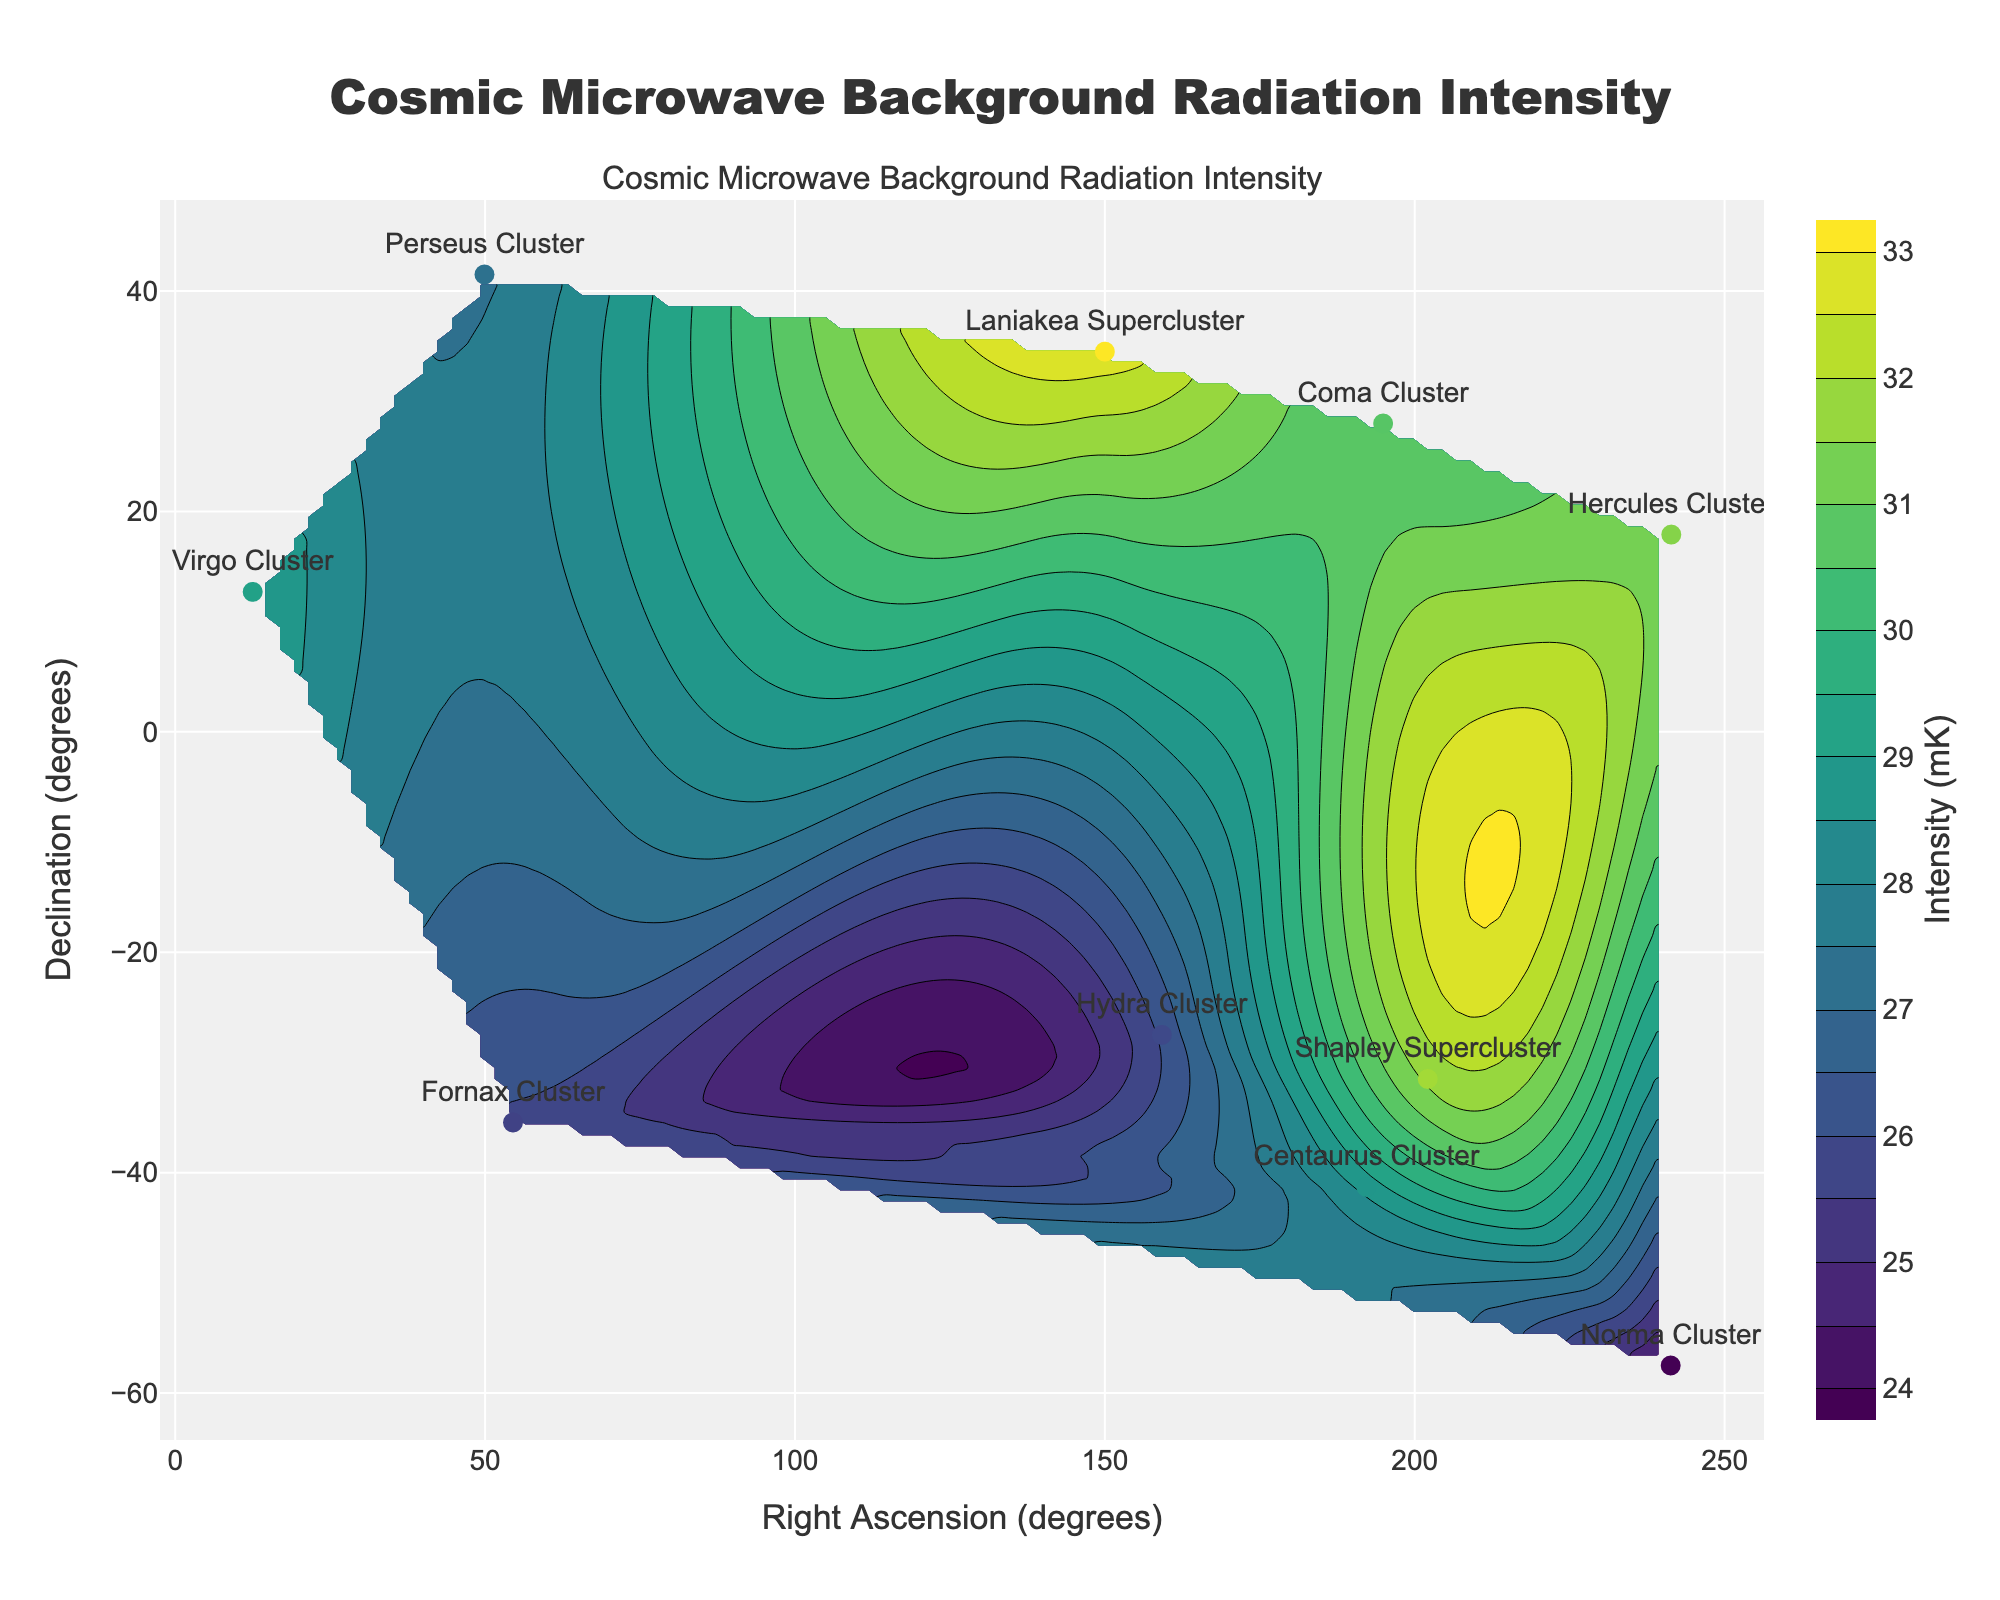What's the title of the figure? The title of the figure is displayed prominently at the top-center of the plot.
Answer: Cosmic Microwave Background Radiation Intensity What are the x-axis and y-axis titles? The x-axis title is displayed below the x-axis, and the y-axis title is displayed to the left of the y-axis.
Answer: Right Ascension (degrees), Declination (degrees) How many data points are plotted on the scatter plot? The scatter plot shows 10 distinct markers with labels indicating the regions of the universe.
Answer: 10 Which cluster has the highest cosmic microwave background radiation intensity? By checking the region labels next to the highest intensity value on the color bar in the plot, we can find that Laniakea Supercluster has the highest intensity.
Answer: Laniakea Supercluster What range of intensity values are used in the contour plot? The colorbar on the right of the plot indicates the range of contour levels used, from 24 mK to 33 mK.
Answer: 24 mK to 33 mK Which cluster has the lowest intensity? By looking at the scatter plot and comparing the intensity values, Norma Cluster has the lowest intensity at 24.2 mK.
Answer: Norma Cluster How does the intensity of Hercules Cluster compare to Hydra Cluster? By comparing the intensity values shown next to the markers, Hercules Cluster has higher intensity (31.2 mK) compared to Hydra Cluster (26.1 mK).
Answer: Hercules Cluster is higher What is the average intensity of the 10 clusters? Sum all the intensity values (29.1 + 27.4 + 30.5 + 28.7 + 26.1 + 25.9 + 24.2 + 31.6 + 31.2 + 32.8) and divide by the number of clusters (10). The total is 287.5, so the average is 287.5 / 10 = 28.75 mK.
Answer: 28.75 mK What regions lie within a declination range of -30 to 30 degrees? Check the declination (y-axis) values of each region and find those that fall within the given range: Virgo Cluster (12.7), Perseus Cluster (41.5), Coma Cluster (27.98), Hydra Cluster (-27.5), Shapley Supercluster (-31.5), Laniakea Supercluster (34.5). Except "Perseus Cluster" and "Laniakea Supercluster," the others lie within the range.
Answer: Virgo Cluster, Coma Cluster, Hydra Cluster, Shapley Supercluster Which region has right ascension greater than 200 and what is its intensity? Locate the regions on the scatter plot and find those with a right ascension (x-axis) value greater than 200 degrees: Norma Cluster and Shapley Supercluster. The intensity value for Shapley Supercluster is 31.6 mK.
Answer: Shapley Supercluster, 31.6 mK 